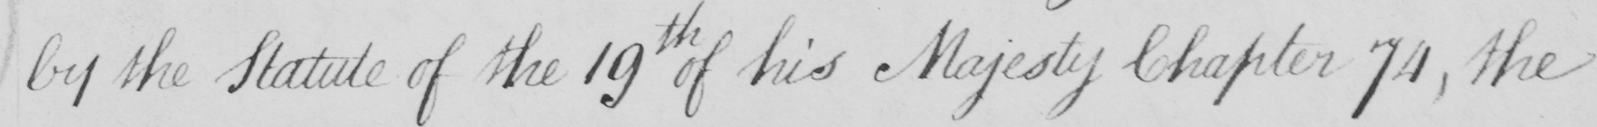Can you tell me what this handwritten text says? by the Statute of the 19th of his Majesty Chapter 74 , the 